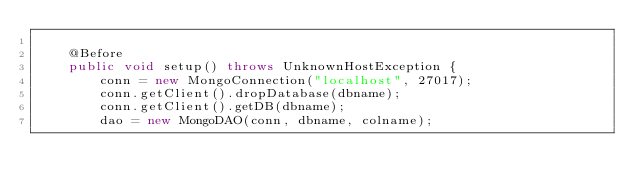Convert code to text. <code><loc_0><loc_0><loc_500><loc_500><_Java_>
	@Before
	public void setup() throws UnknownHostException {
		conn = new MongoConnection("localhost", 27017);
		conn.getClient().dropDatabase(dbname);
		conn.getClient().getDB(dbname);
		dao = new MongoDAO(conn, dbname, colname);</code> 